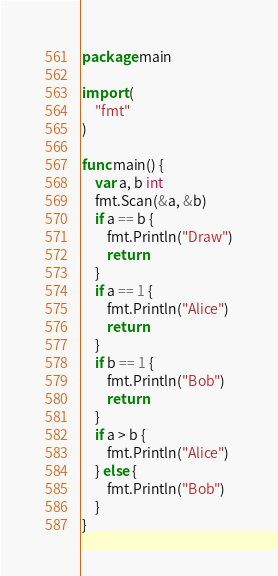Convert code to text. <code><loc_0><loc_0><loc_500><loc_500><_Go_>package main

import (
	"fmt"
)

func main() {
	var a, b int
	fmt.Scan(&a, &b)
	if a == b {
		fmt.Println("Draw")
		return
	}
	if a == 1 {
		fmt.Println("Alice")
		return
	}
	if b == 1 {
		fmt.Println("Bob")
		return
	}
	if a > b {
		fmt.Println("Alice")
	} else {
		fmt.Println("Bob")
	}
}
</code> 